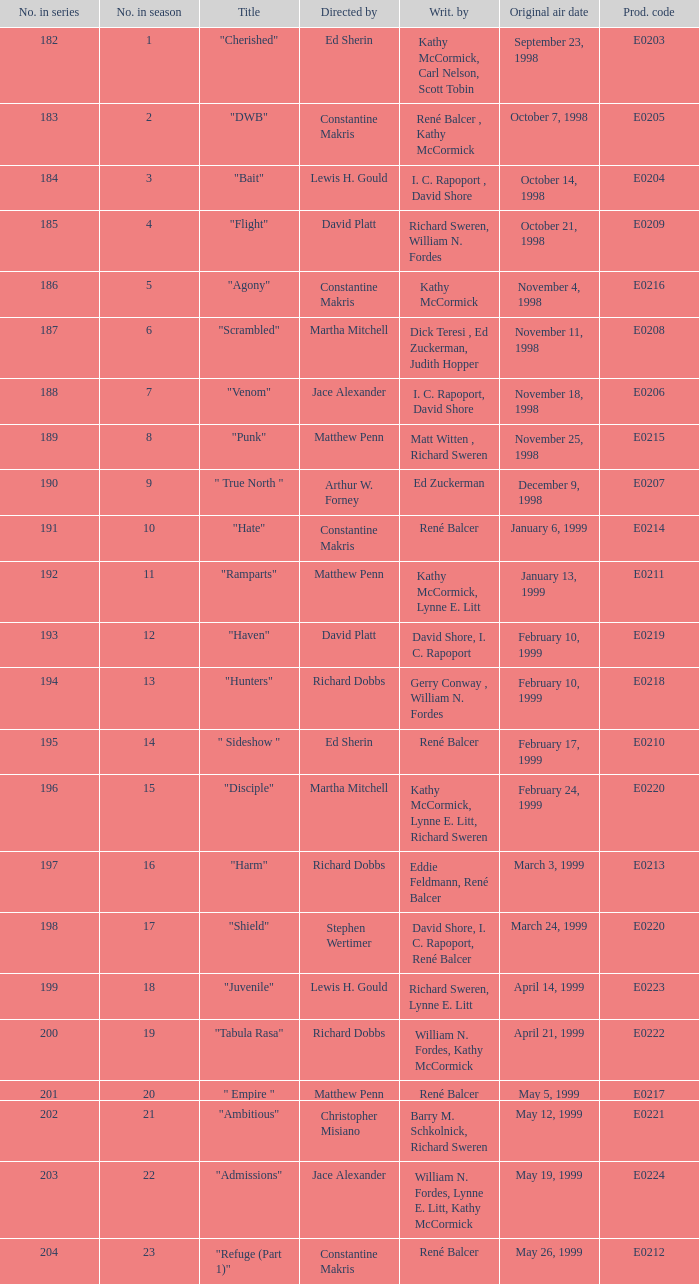The episode with the production code E0208 is directed by who? Martha Mitchell. 